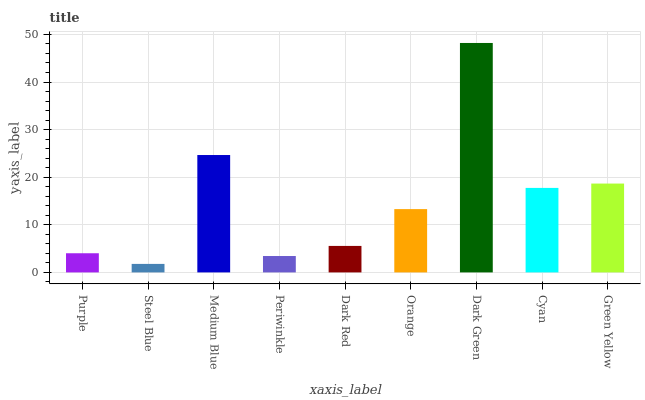Is Steel Blue the minimum?
Answer yes or no. Yes. Is Dark Green the maximum?
Answer yes or no. Yes. Is Medium Blue the minimum?
Answer yes or no. No. Is Medium Blue the maximum?
Answer yes or no. No. Is Medium Blue greater than Steel Blue?
Answer yes or no. Yes. Is Steel Blue less than Medium Blue?
Answer yes or no. Yes. Is Steel Blue greater than Medium Blue?
Answer yes or no. No. Is Medium Blue less than Steel Blue?
Answer yes or no. No. Is Orange the high median?
Answer yes or no. Yes. Is Orange the low median?
Answer yes or no. Yes. Is Periwinkle the high median?
Answer yes or no. No. Is Periwinkle the low median?
Answer yes or no. No. 